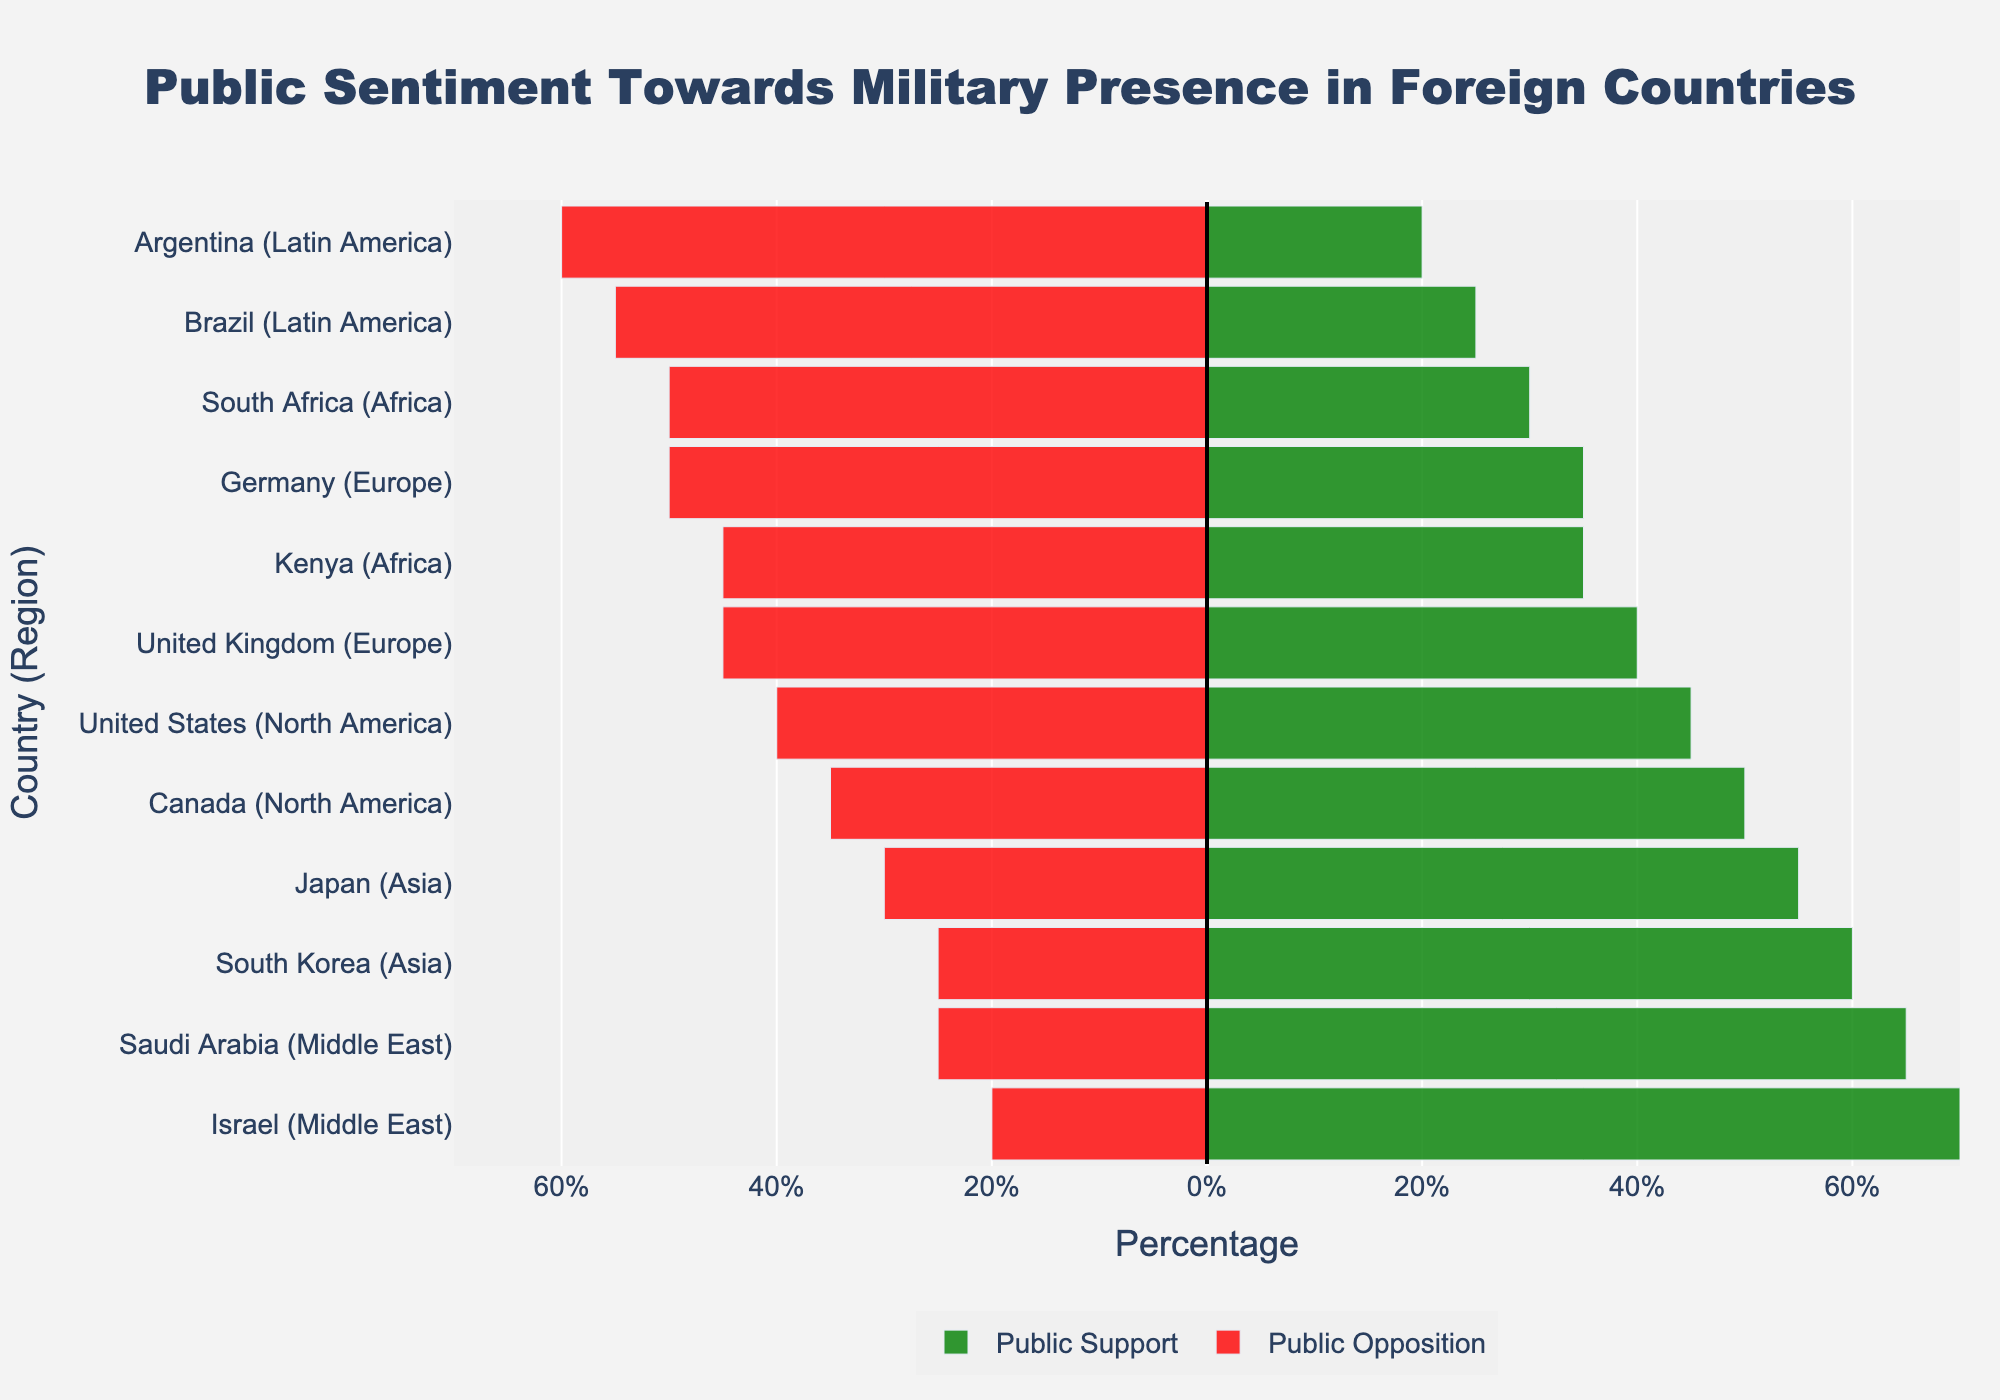What regions have countries with the highest and lowest public support for military presence? Looking at the bar chart, the Middle East region stands out with Israel having the highest public support at 70%. Latin America has the lowest public support with Argentina at 20%.
Answer: Middle East (Highest: Israel at 70%), Latin America (Lowest: Argentina at 20%) Which country in Europe has a higher opposition to military presence, Germany or the United Kingdom? By comparing the lengths of the red bars for Germany and the United Kingdom, we can see that Germany has a longer red bar at 50% opposition, while the United Kingdom has a 45% opposition.
Answer: Germany What is the difference in public support between Japan and South Korea? The public support for Japan is 55%, while for South Korea, it is 60%. Subtracting these, we get 60% - 55% = 5%.
Answer: 5% What's the average public support for military presence across all countries in North America? North America includes the United States and Canada. The public support is 45% for the United States and 50% for Canada. The average is (45% + 50%) / 2 = 47.5%.
Answer: 47.5% Compare the public sentiment balance (net support) for military presence in Saudi Arabia and South Africa. Which country has a more positive sentiment? Net support for Saudi Arabia is 65% support - 25% opposition = 40%. For South Africa, it's 30% support - 50% opposition = -20%. Saudi Arabia's sentiment is more positive by 60%.
Answer: Saudi Arabia Which countries have a neutrality percentage of 15% and how does their support compare to opposition? The countries with 15% neutrality are the United States, Canada, United Kingdom, Germany, Japan, and South Korea. Their support compared to opposition is: United States (45% support, 40% opposition, net 5%), Canada (50% support, 35% opposition, net 15%), United Kingdom (40% support, 45% opposition, net -5%), Germany (35% support, 50% opposition, net -15%), Japan (55% support, 30% opposition, net 25%), South Korea (60% support, 25% opposition, net 35%).
Answer: United States, Canada, United Kingdom, Germany, Japan, South Korea What region has the most neutral/no opinion sentiment overall? Summing up the neutral/no opinion percentages for each region and comparing them, Africa (20% South Africa, 20% Kenya), and Latin America (20% Brazil, 20% Argentina) have the highest neutrality at 40%.
Answer: Africa and Latin America Is the public opposition to military presence generally higher in Europe or Asia? In Europe, the opposition percentages are 45% (United Kingdom) and 50% (Germany). In Asia, they are 30% (Japan) and 25% (South Korea). With higher values in Europe (average 47.5%) compared to Asia (average 27.5%), Europe has generally higher public opposition.
Answer: Europe 